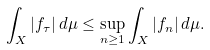<formula> <loc_0><loc_0><loc_500><loc_500>\int _ { X } | f _ { \tau } | \, d \mu \leq \sup _ { n \geq 1 } \int _ { X } | f _ { n } | \, d \mu .</formula> 